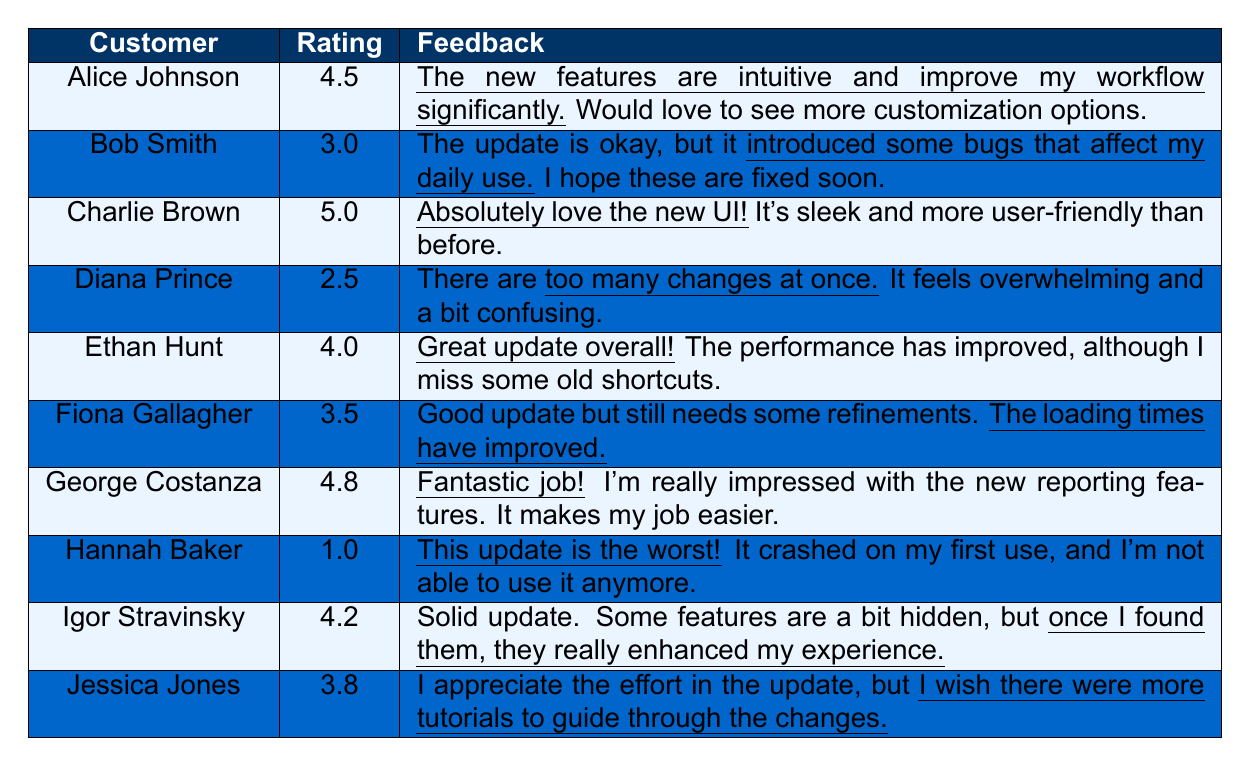What is the highest customer feedback rating? Looking at the ratings in the table, the highest rating is given by Charlie Brown, who rated it 5.0
Answer: 5.0 Who provided the lowest rating for the web application update? The lowest rating comes from Hannah Baker, who gave a rating of 1.0
Answer: Hannah Baker What feedback did George Costanza provide? George Costanza's feedback states, "Fantastic job! I’m really impressed with the new reporting features."
Answer: Fantastic job! I’m really impressed with the new reporting features How many customers rated the application above 4.0? The customers with ratings above 4.0 are Alice Johnson, Charlie Brown, George Costanza, Ethan Hunt, and Igor Stravinsky, totaling 5 customers.
Answer: 5 What is the average rating from the customer feedback? To calculate the average, sum all the ratings: 4.5 + 3.0 + 5.0 + 2.5 + 4.0 + 3.5 + 4.8 + 1.0 + 4.2 + 3.8 = 36.3. There are 10 ratings, so the average is 36.3 / 10 = 3.63
Answer: 3.63 Did any customer mention experiencing bugs after the update? Yes, Bob Smith specifically mentioned that the update introduced some bugs affecting his daily use.
Answer: Yes Which customer expressed a desire for more tutorials? Jessica Jones indicated a wish for more tutorials to help guide through the changes in the update.
Answer: Jessica Jones How many customers did not rate the application above 3.5? The customers who rated at or below 3.5 are Bob Smith, Diana Prince, Fiona Gallagher, Hannah Baker, and Jessica Jones, totaling 5 customers.
Answer: 5 What feedback did Alice Johnson give about the new features? Alice Johnson's feedback described the new features as intuitive and a significant improvement to her workflow.
Answer: The new features are intuitive and improve my workflow significantly Was there a customer who found the update overwhelming? Yes, Diana Prince felt that there were too many changes at once, making it overwhelming and confusing.
Answer: Yes Which customer was most impressed with the UI? Charlie Brown was the most impressed with the UI, describing it as sleek and more user-friendly.
Answer: Charlie Brown 